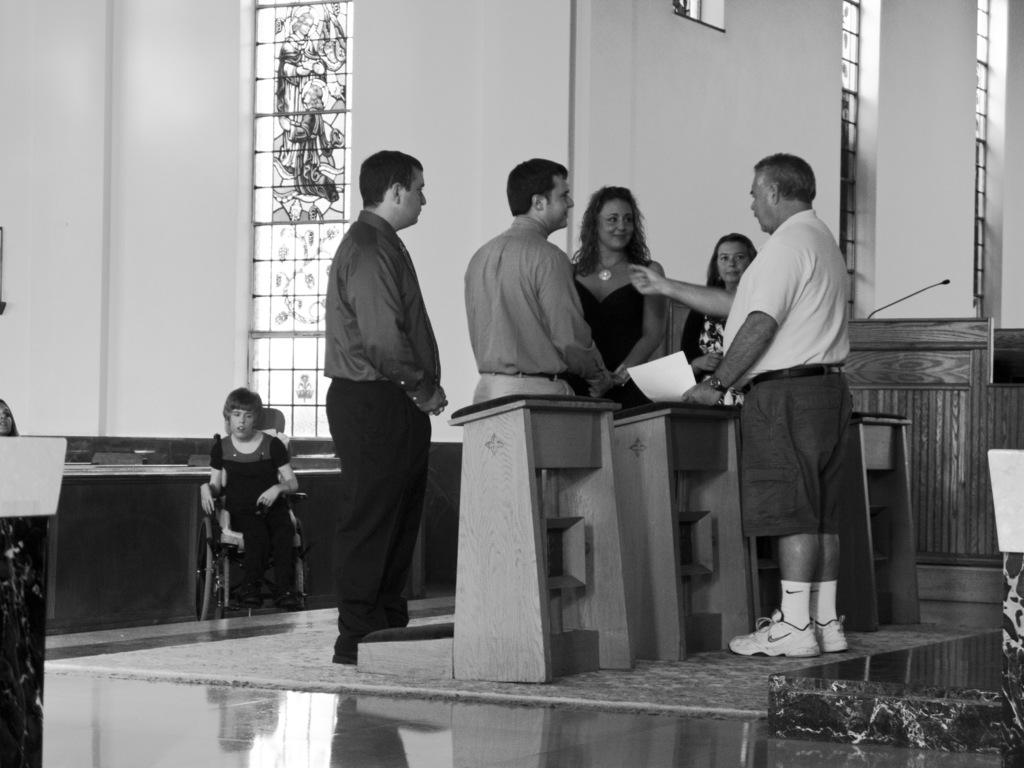How many people are in the image? There are five persons in the image. Where are the persons located in the image? The persons are standing on a stage. What is visible behind the stage? There is a wall behind the stage. What type of map can be seen on the stage in the image? There is no map present on the stage in the image. What kind of competition are the persons participating in on the stage? There is no indication of a competition in the image; the persons are simply standing on a stage. 